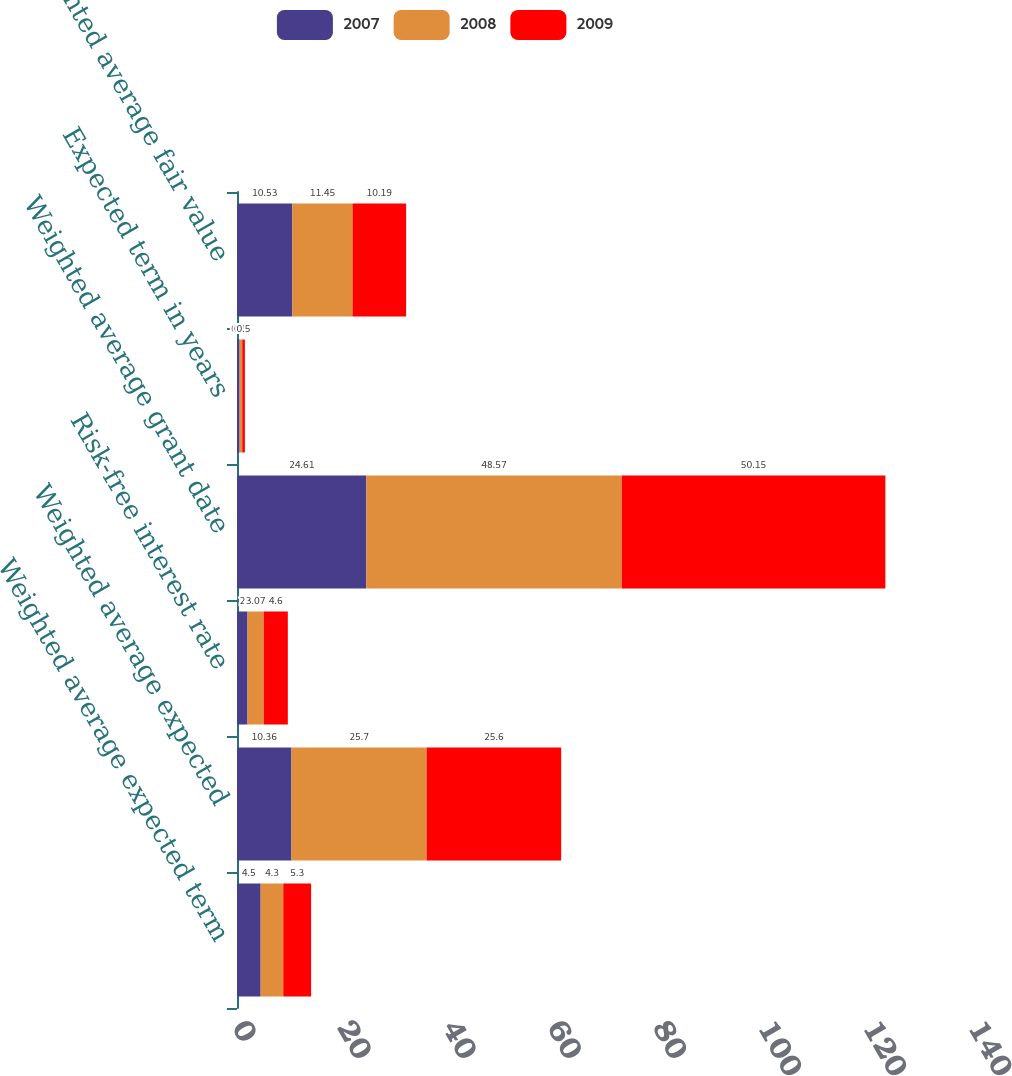Convert chart. <chart><loc_0><loc_0><loc_500><loc_500><stacked_bar_chart><ecel><fcel>Weighted average expected term<fcel>Weighted average expected<fcel>Risk-free interest rate<fcel>Weighted average grant date<fcel>Expected term in years<fcel>Weighted average fair value<nl><fcel>2007<fcel>4.5<fcel>10.36<fcel>2<fcel>24.61<fcel>0.5<fcel>10.53<nl><fcel>2008<fcel>4.3<fcel>25.7<fcel>3.07<fcel>48.57<fcel>0.5<fcel>11.45<nl><fcel>2009<fcel>5.3<fcel>25.6<fcel>4.6<fcel>50.15<fcel>0.5<fcel>10.19<nl></chart> 